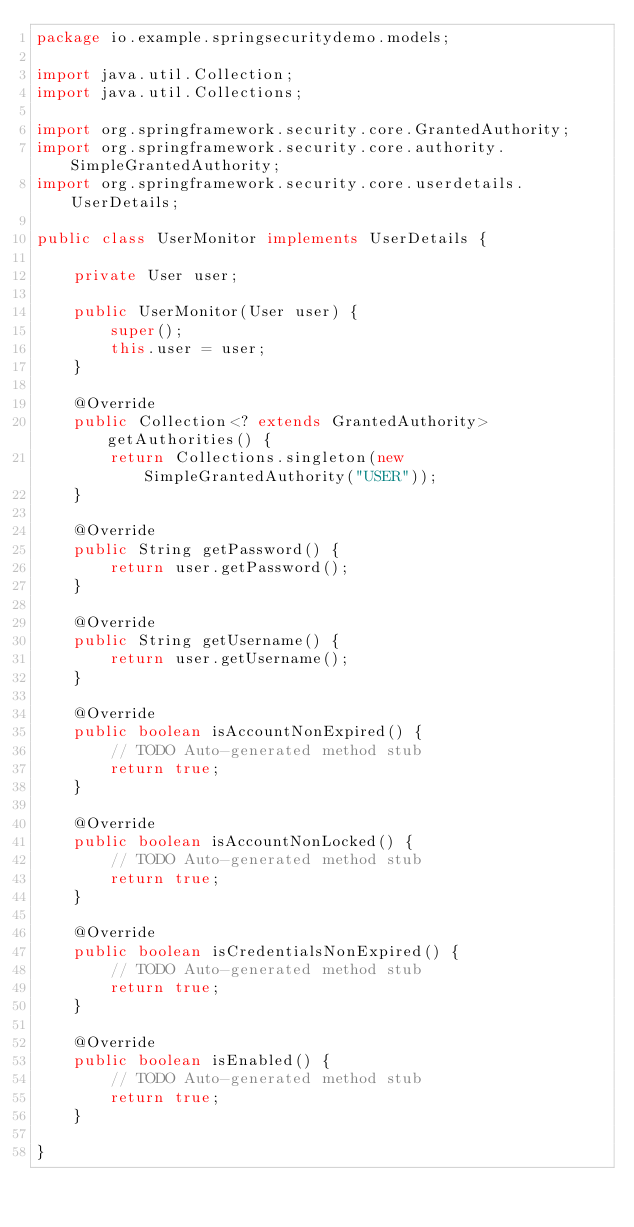<code> <loc_0><loc_0><loc_500><loc_500><_Java_>package io.example.springsecuritydemo.models;

import java.util.Collection;
import java.util.Collections;

import org.springframework.security.core.GrantedAuthority;
import org.springframework.security.core.authority.SimpleGrantedAuthority;
import org.springframework.security.core.userdetails.UserDetails;

public class UserMonitor implements UserDetails {

	private User user;
	
	public UserMonitor(User user) {
		super();
		this.user = user;
	}

	@Override
	public Collection<? extends GrantedAuthority> getAuthorities() {
		return Collections.singleton(new SimpleGrantedAuthority("USER"));
	}

	@Override
	public String getPassword() {
		return user.getPassword();
	}

	@Override
	public String getUsername() {
		return user.getUsername();
	}

	@Override
	public boolean isAccountNonExpired() {
		// TODO Auto-generated method stub
		return true;
	}

	@Override
	public boolean isAccountNonLocked() {
		// TODO Auto-generated method stub
		return true;
	}

	@Override
	public boolean isCredentialsNonExpired() {
		// TODO Auto-generated method stub
		return true;
	}

	@Override
	public boolean isEnabled() {
		// TODO Auto-generated method stub
		return true;
	}

}
</code> 